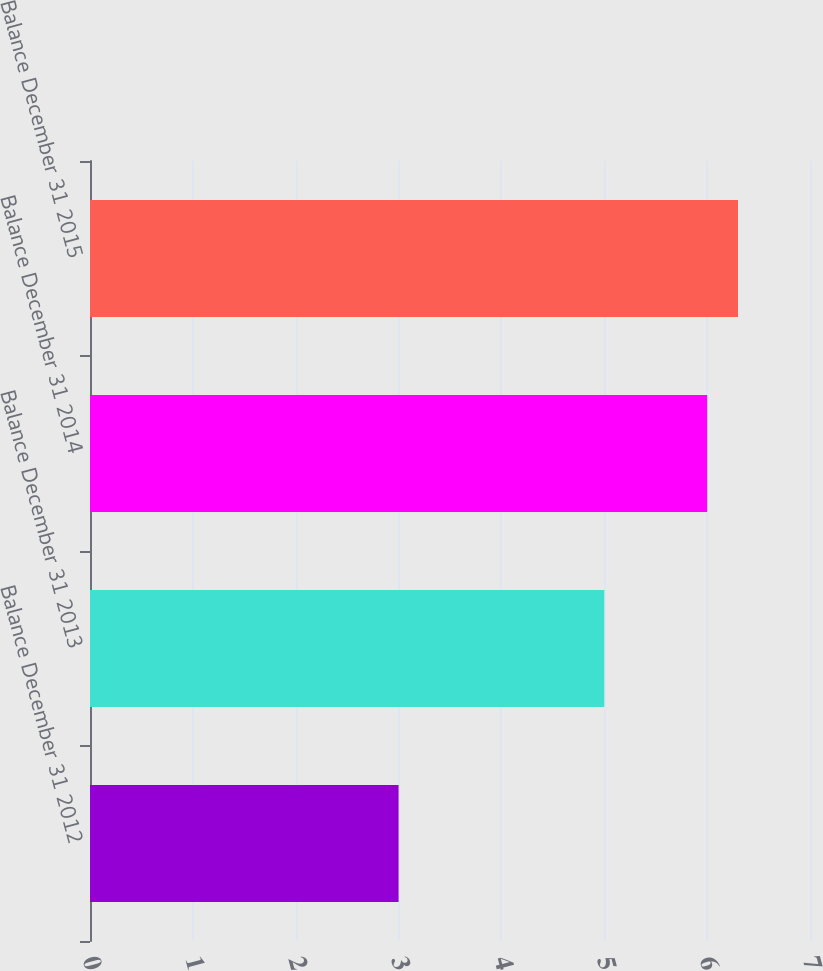Convert chart. <chart><loc_0><loc_0><loc_500><loc_500><bar_chart><fcel>Balance December 31 2012<fcel>Balance December 31 2013<fcel>Balance December 31 2014<fcel>Balance December 31 2015<nl><fcel>3<fcel>5<fcel>6<fcel>6.3<nl></chart> 